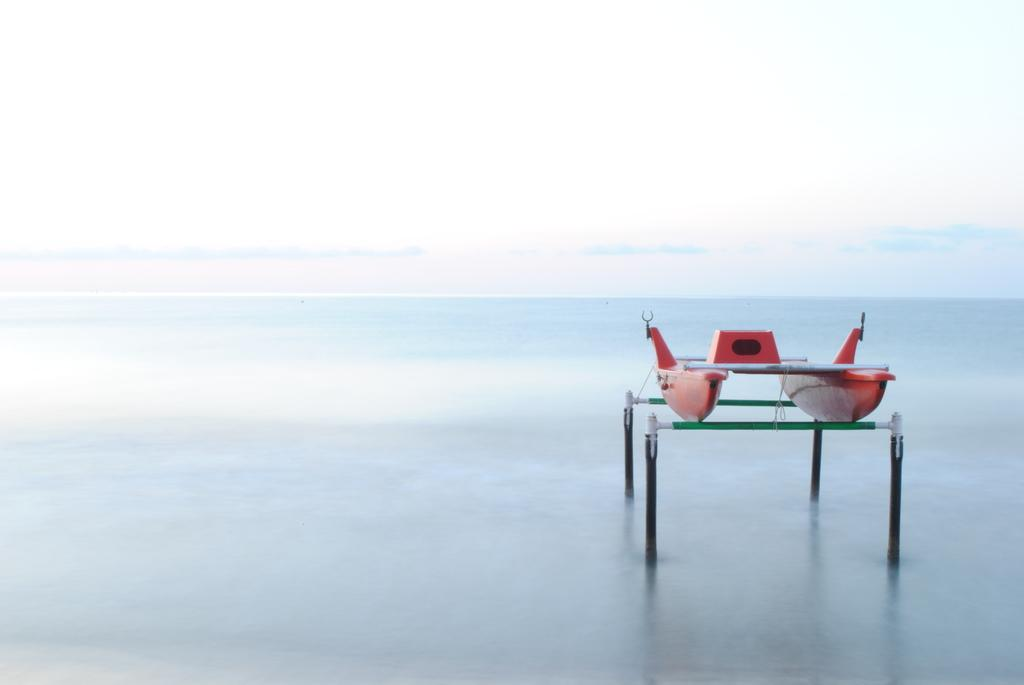What is located in the front of the image? There is a boat in the front of the image. What else can be seen in the front of the image besides the boat? There are rods and water in the front of the image. What is visible in the background of the image? The sky is visible in the background of the image. What type of grain is being harvested on the page in the image? There is no grain or page present in the image; it features a boat, rods, and water in the front, with the sky visible in the background. 